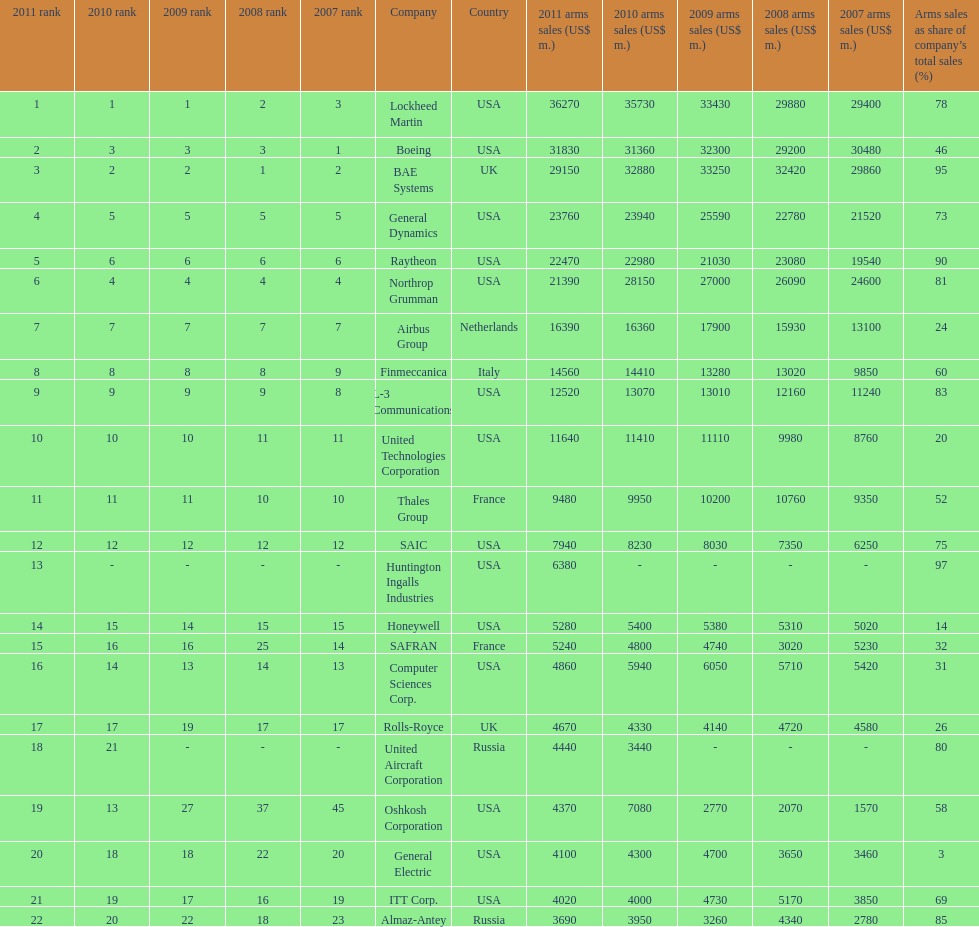Name all the companies whose arms sales as share of company's total sales is below 75%. Boeing, General Dynamics, Airbus Group, Finmeccanica, United Technologies Corporation, Thales Group, Honeywell, SAFRAN, Computer Sciences Corp., Rolls-Royce, Oshkosh Corporation, General Electric, ITT Corp. 